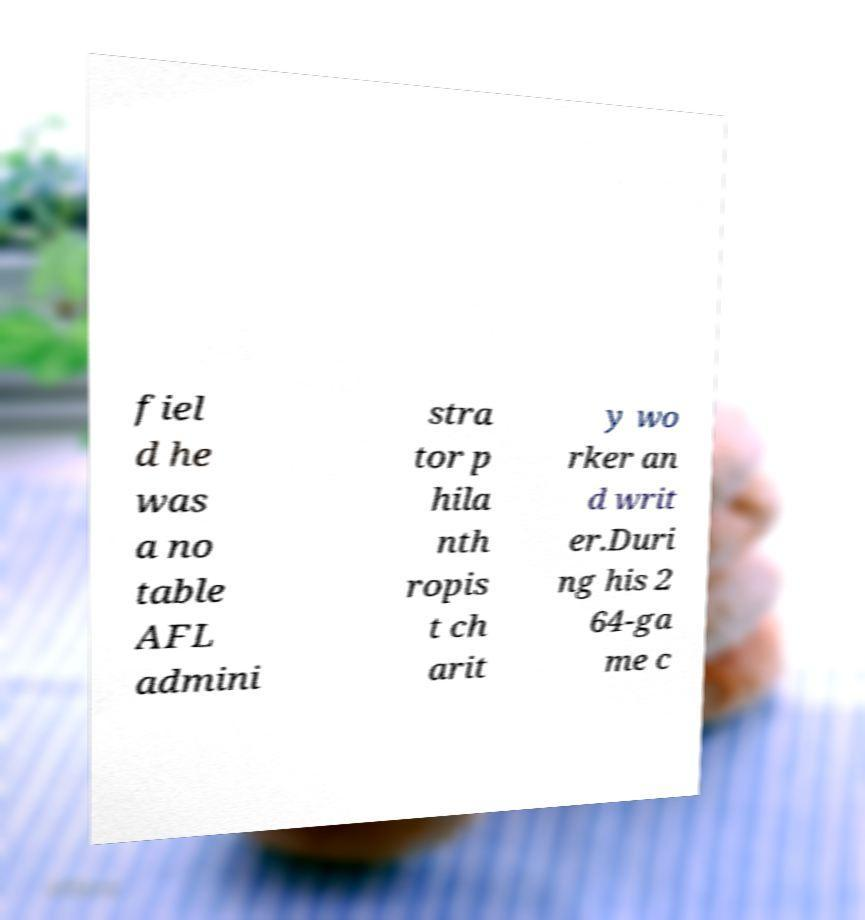Could you assist in decoding the text presented in this image and type it out clearly? fiel d he was a no table AFL admini stra tor p hila nth ropis t ch arit y wo rker an d writ er.Duri ng his 2 64-ga me c 